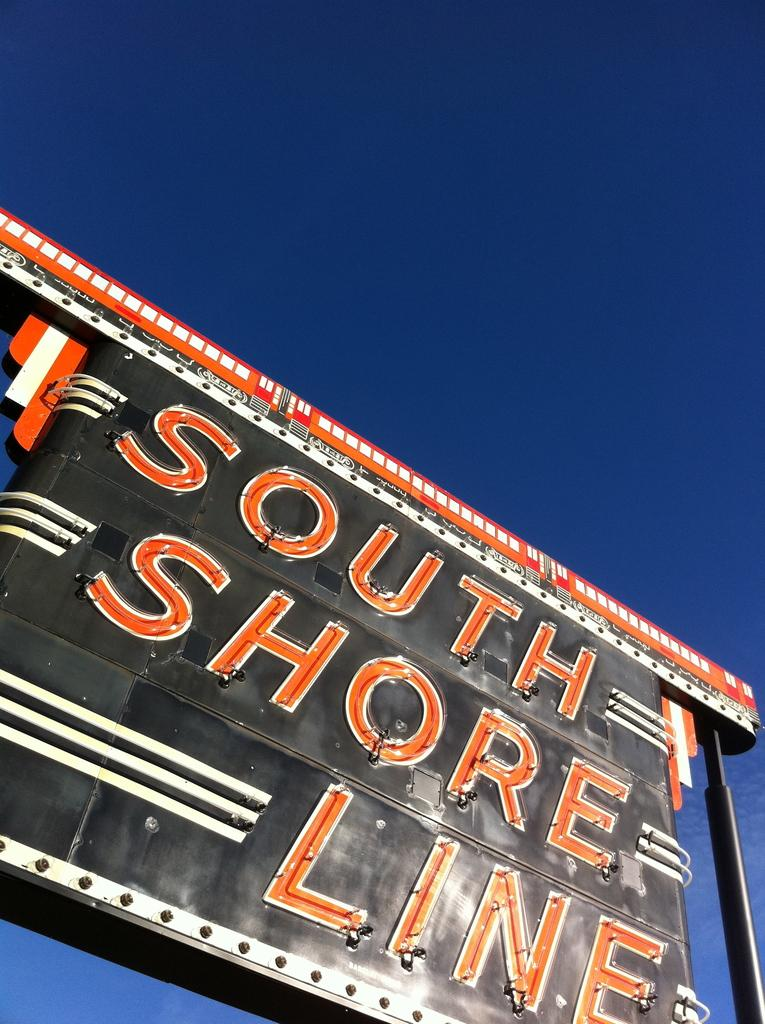<image>
Write a terse but informative summary of the picture. A sign saying, "South Shore Line" in orange font with the sun shining on it. 